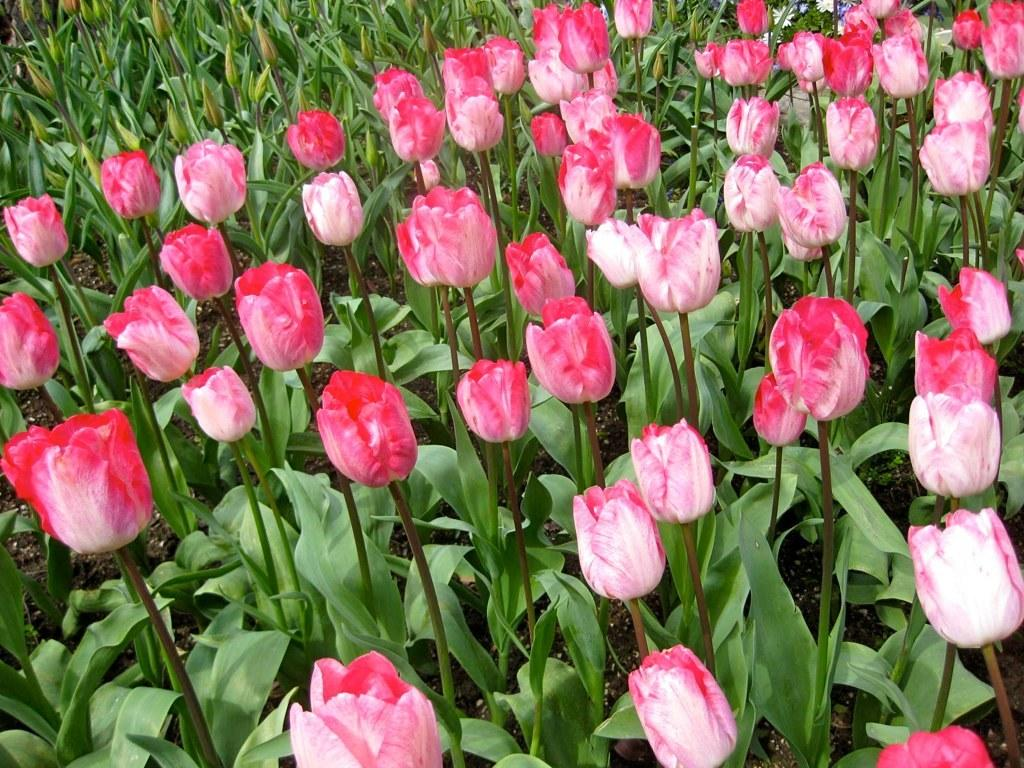What type of living organisms are in the image? The image contains plants. What specific characteristic do the plants have? The plants have pink tulip flowers. What type of collar can be seen on the goose in the image? There is no goose present in the image, and therefore no collar can be seen. 